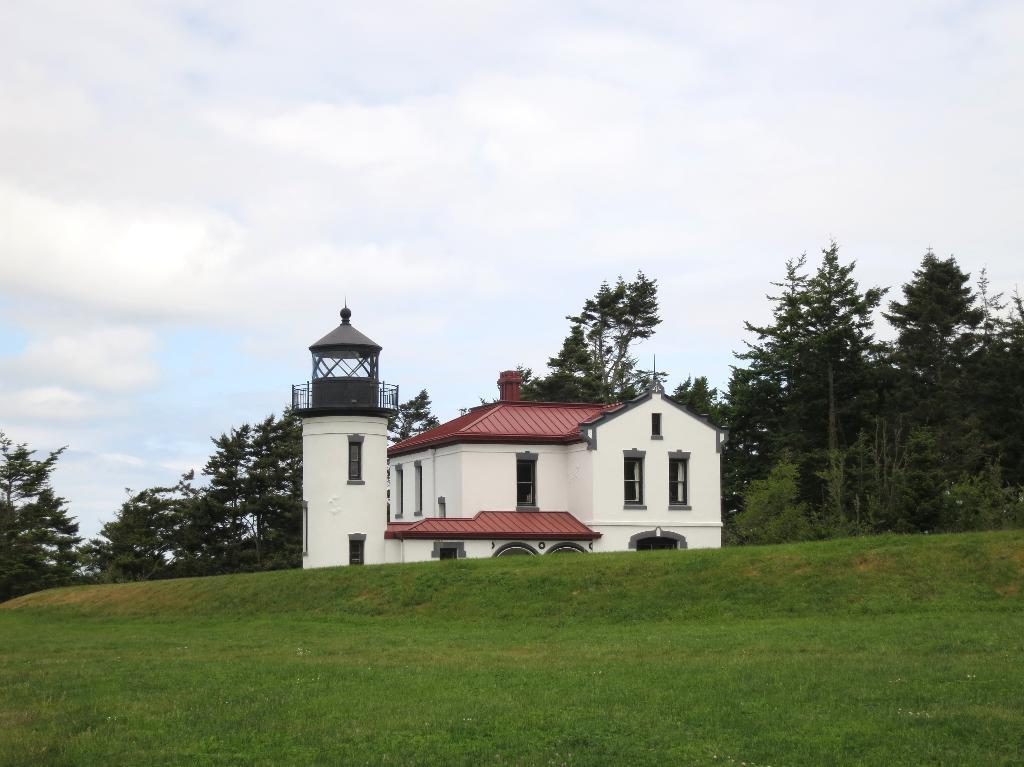What type of vegetation is visible in the foreground of the picture? There is grass in the foreground of the picture. What can be seen in the center of the picture? There are trees and a house in the center of the picture. What is the condition of the sky in the picture? The sky is cloudy in the picture. Is there a bear holding a quiver in the picture? No, there is no bear or quiver present in the picture. The image features grass, trees, a house, and a cloudy sky. 